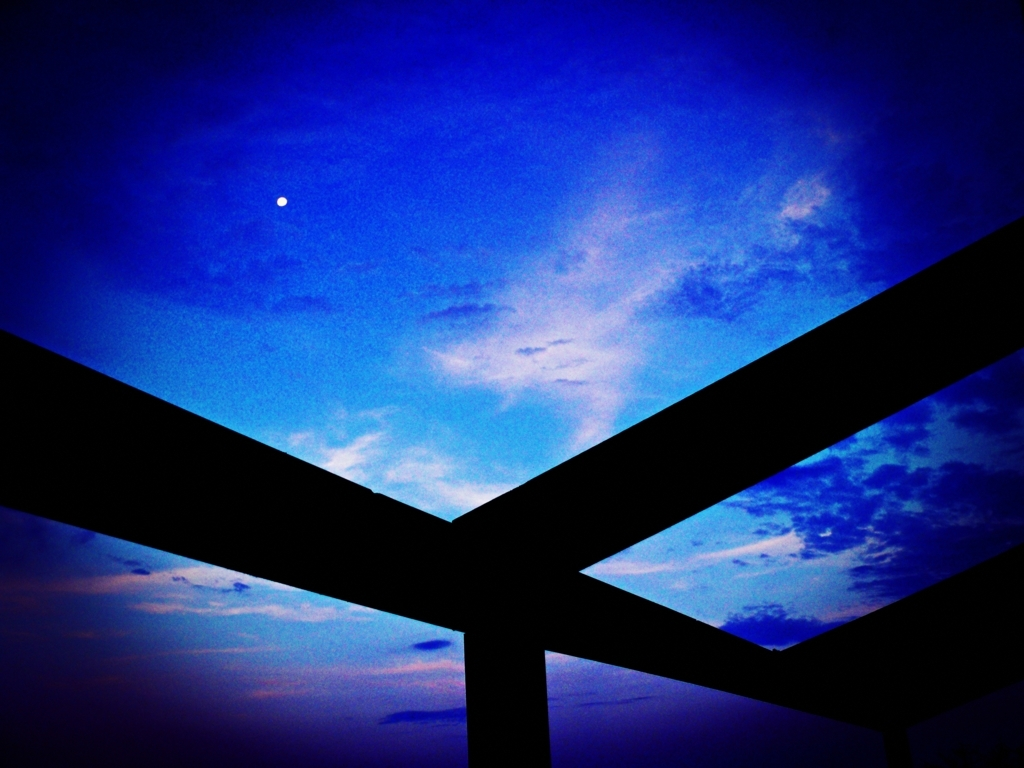How would you describe the image?
A. clear and sharp
B. vibrant and colorful
C. blurry and noisy
D. detailed and precise
Answer with the option's letter from the given choices directly. While the image does possess a certain graininess that might suggest 'blurry and noisy', choice 'B. vibrant and colorful' is a more accurate description. It features a rich blue palette with an array of deeper and lighter tones, contrasting with dark silhouetted shapes that frame the composition. The image exudes an atmosphere of calmness during what appears to be twilight, with a hint of mystery introduced by the lone visible dot in the sky, possibly an early evening star or a distant planet. 